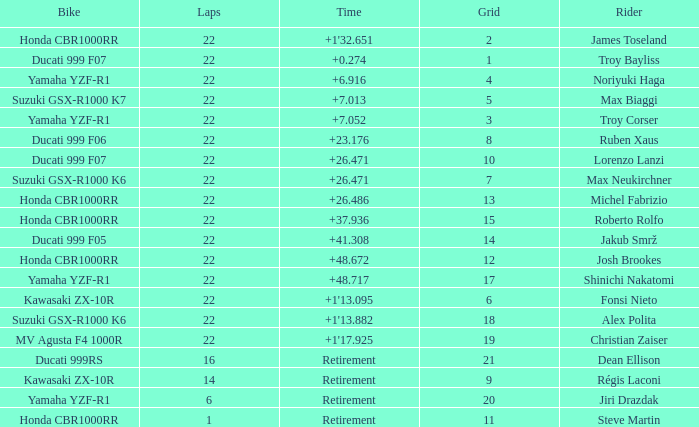What is the total grid number when Fonsi Nieto had more than 22 laps? 0.0. I'm looking to parse the entire table for insights. Could you assist me with that? {'header': ['Bike', 'Laps', 'Time', 'Grid', 'Rider'], 'rows': [['Honda CBR1000RR', '22', "+1'32.651", '2', 'James Toseland'], ['Ducati 999 F07', '22', '+0.274', '1', 'Troy Bayliss'], ['Yamaha YZF-R1', '22', '+6.916', '4', 'Noriyuki Haga'], ['Suzuki GSX-R1000 K7', '22', '+7.013', '5', 'Max Biaggi'], ['Yamaha YZF-R1', '22', '+7.052', '3', 'Troy Corser'], ['Ducati 999 F06', '22', '+23.176', '8', 'Ruben Xaus'], ['Ducati 999 F07', '22', '+26.471', '10', 'Lorenzo Lanzi'], ['Suzuki GSX-R1000 K6', '22', '+26.471', '7', 'Max Neukirchner'], ['Honda CBR1000RR', '22', '+26.486', '13', 'Michel Fabrizio'], ['Honda CBR1000RR', '22', '+37.936', '15', 'Roberto Rolfo'], ['Ducati 999 F05', '22', '+41.308', '14', 'Jakub Smrž'], ['Honda CBR1000RR', '22', '+48.672', '12', 'Josh Brookes'], ['Yamaha YZF-R1', '22', '+48.717', '17', 'Shinichi Nakatomi'], ['Kawasaki ZX-10R', '22', "+1'13.095", '6', 'Fonsi Nieto'], ['Suzuki GSX-R1000 K6', '22', "+1'13.882", '18', 'Alex Polita'], ['MV Agusta F4 1000R', '22', "+1'17.925", '19', 'Christian Zaiser'], ['Ducati 999RS', '16', 'Retirement', '21', 'Dean Ellison'], ['Kawasaki ZX-10R', '14', 'Retirement', '9', 'Régis Laconi'], ['Yamaha YZF-R1', '6', 'Retirement', '20', 'Jiri Drazdak'], ['Honda CBR1000RR', '1', 'Retirement', '11', 'Steve Martin']]} 